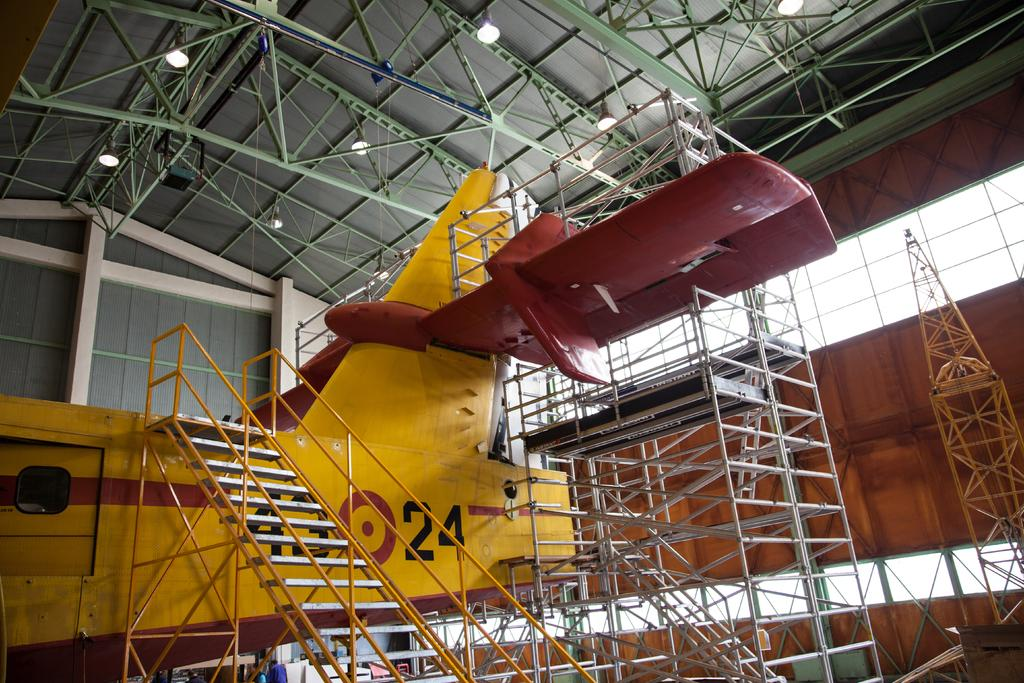<image>
Create a compact narrative representing the image presented. A yellow plane has staircases attached to it and the number 24 on the side. 